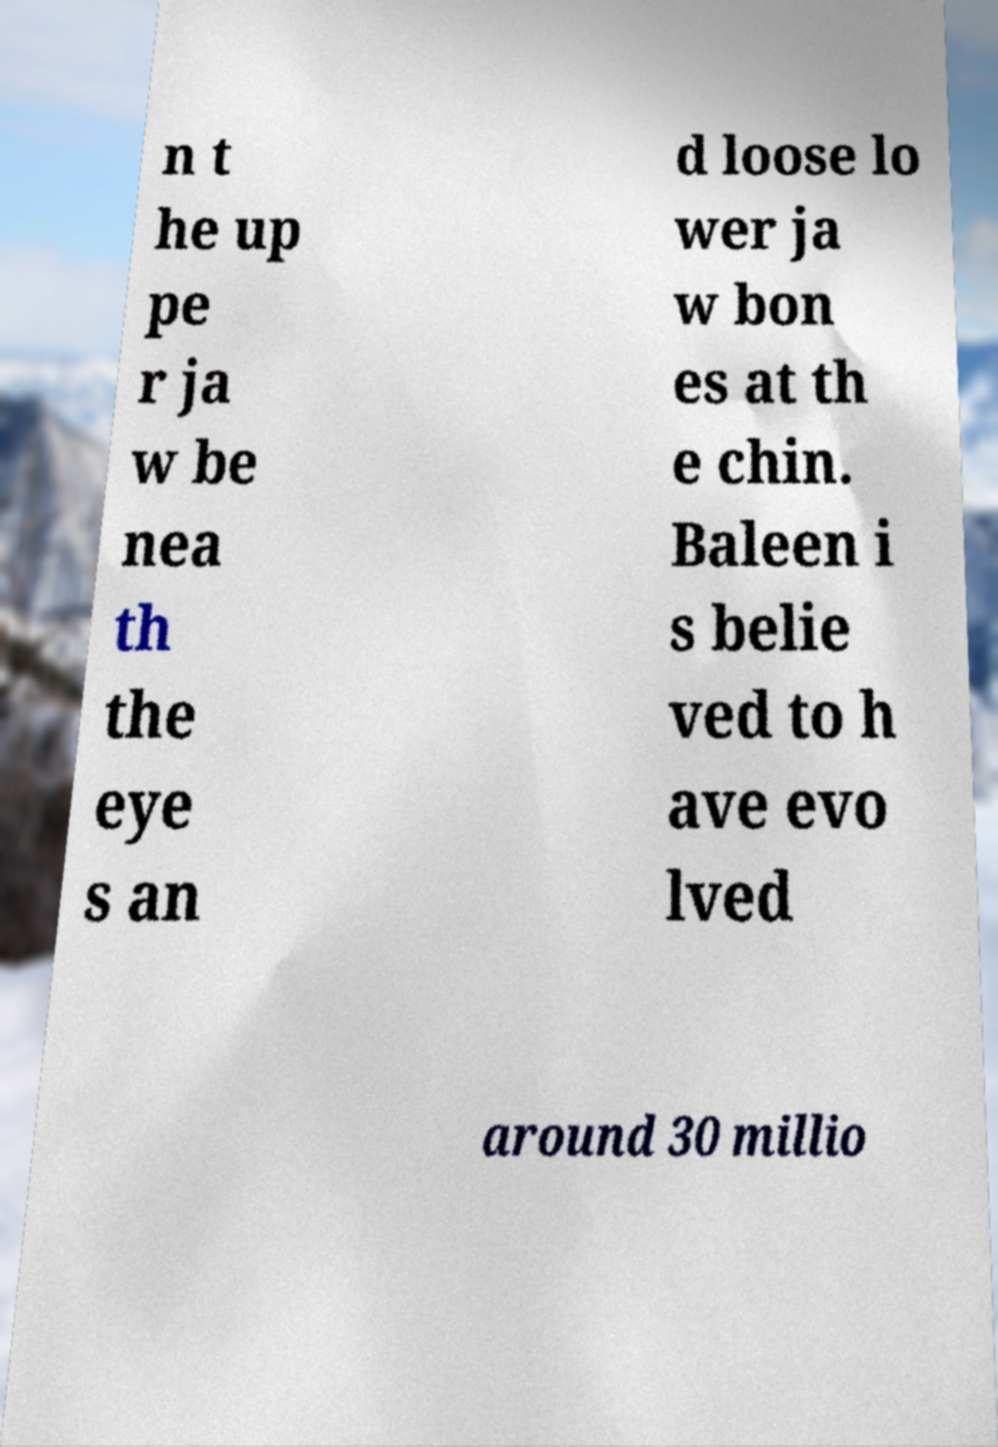Can you read and provide the text displayed in the image?This photo seems to have some interesting text. Can you extract and type it out for me? n t he up pe r ja w be nea th the eye s an d loose lo wer ja w bon es at th e chin. Baleen i s belie ved to h ave evo lved around 30 millio 